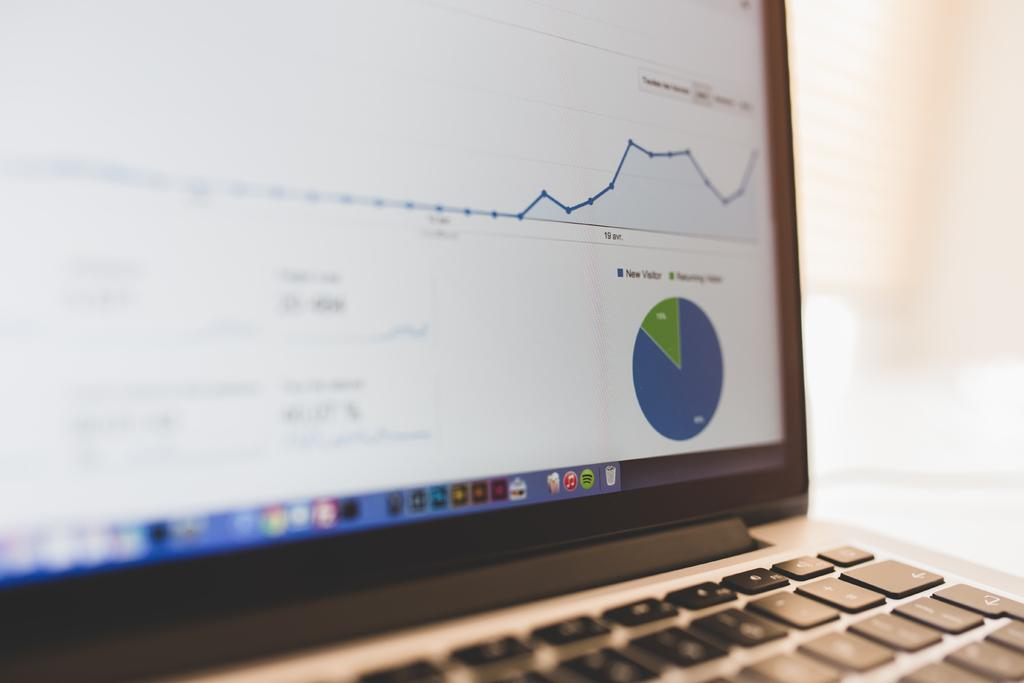<image>
Describe the image concisely. New Visitor is represented in blue on the pie chart. 